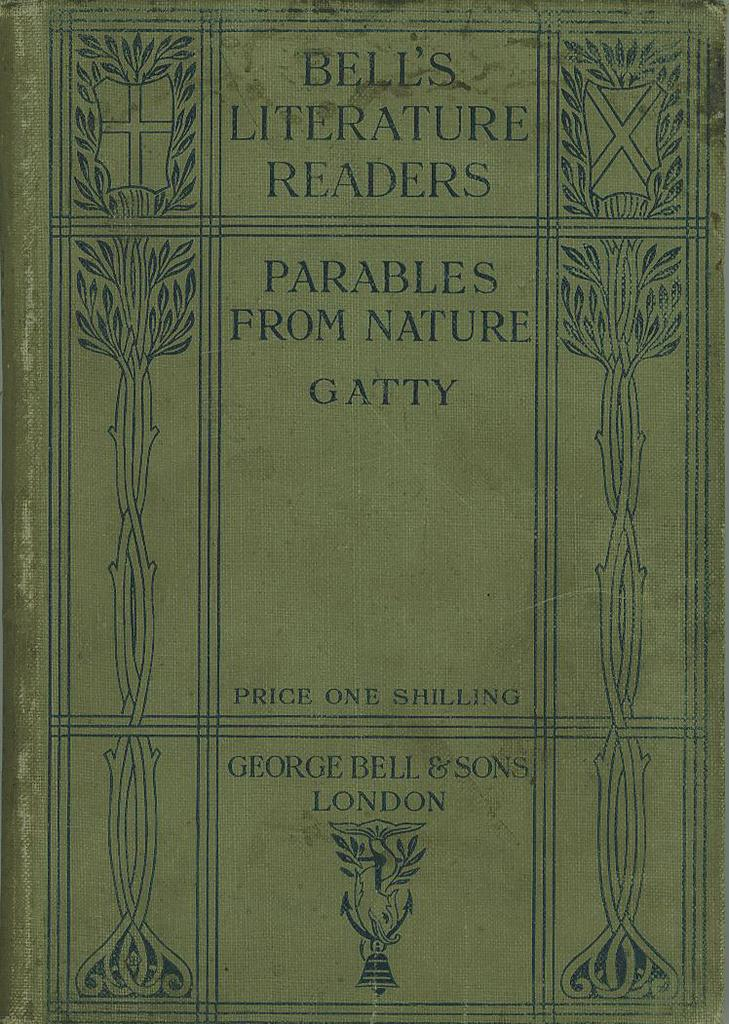Provide a one-sentence caption for the provided image. The front cover of the book Parables From Nature. 